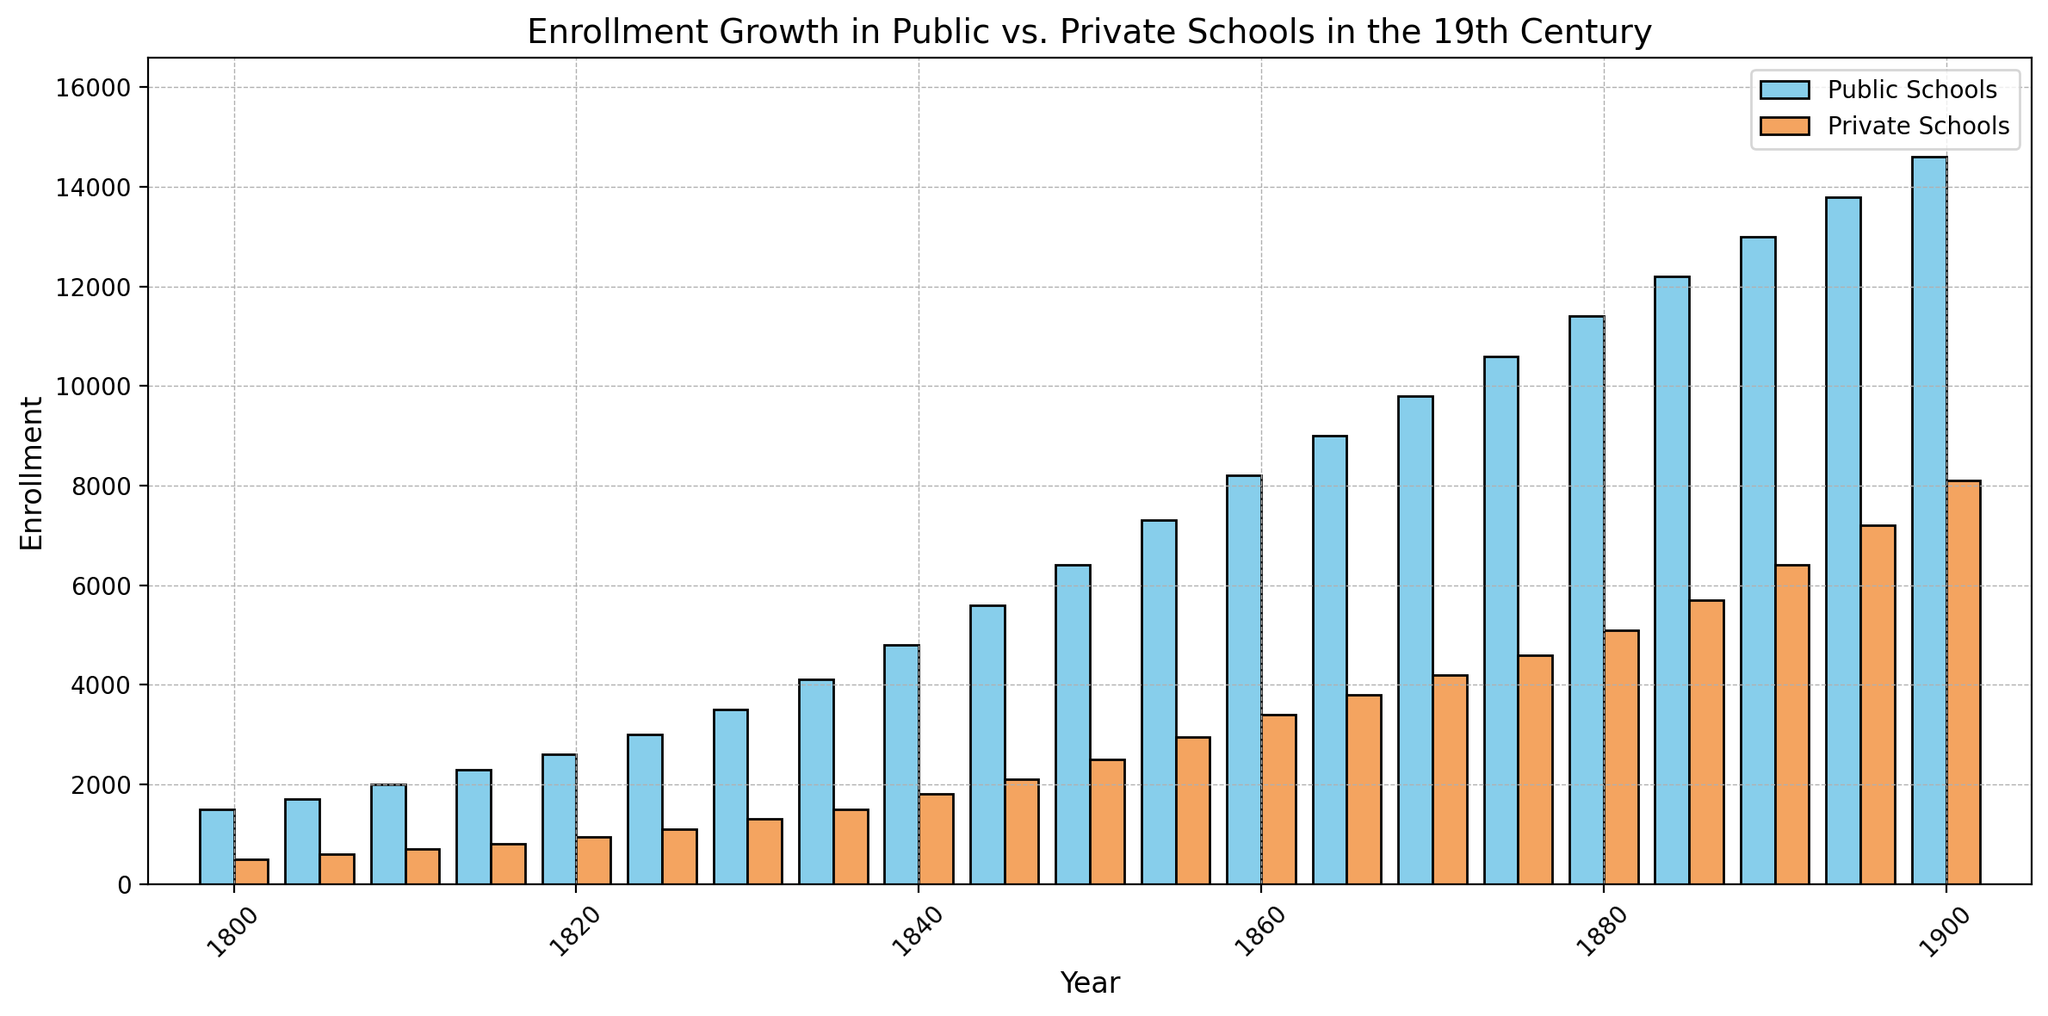What is the overall trend of public school enrollment throughout the 19th century? The visual data shows that the height of the sky blue bars (representing public school enrollment) increases consistently from 1800 to 1900. This indicates a steady and significant growth in public school enrollment over the century.
Answer: Steady growth How does the growth of private school enrollment compare to that of public school enrollment by the end of the century? By examining the sandy brown bars for private enrollment in comparison to the sky blue bars for public enrollment, it’s evident that both enrollments increased. However, the public school enrollment bars are consistently higher and grow at a faster rate, indicating public schools had more growth.
Answer: Public schools grew more In what year did public school enrollment first exceed 10,000? By checking the height of the sky blue bars, the public school enrollment first exceeds 10,000 in the year 1875.
Answer: 1875 By how much did public school enrollment exceed private school enrollment in 1860? The sky blue bar for public school enrollment in 1860 is 8200, while the sandy brown bar for private schools is 3400. The difference is calculated as 8200 - 3400.
Answer: 4800 What was the difference in enrollment between public and private schools in the year 1900? The sky blue bar for public school in 1900 is 14,600 while the sandy brown bar for private school is 8,100. The difference is 14,600 - 8,100 = 6,500.
Answer: 6500 